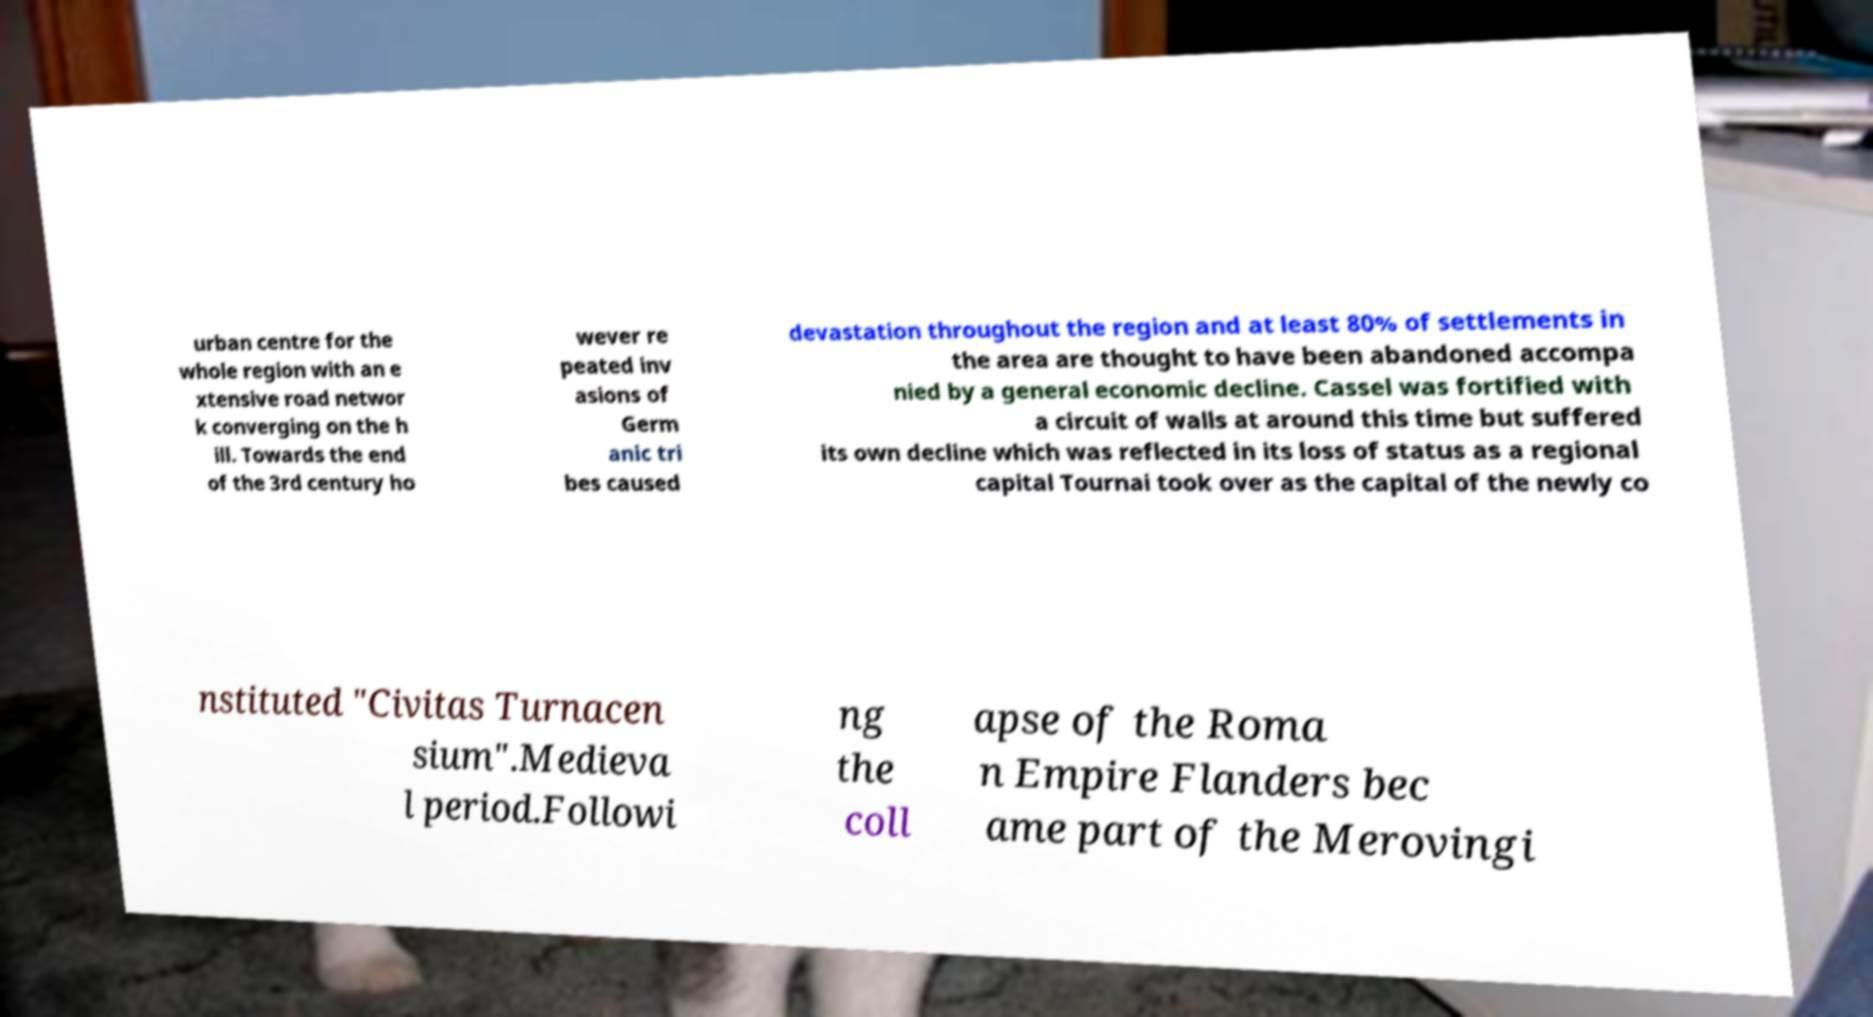There's text embedded in this image that I need extracted. Can you transcribe it verbatim? urban centre for the whole region with an e xtensive road networ k converging on the h ill. Towards the end of the 3rd century ho wever re peated inv asions of Germ anic tri bes caused devastation throughout the region and at least 80% of settlements in the area are thought to have been abandoned accompa nied by a general economic decline. Cassel was fortified with a circuit of walls at around this time but suffered its own decline which was reflected in its loss of status as a regional capital Tournai took over as the capital of the newly co nstituted "Civitas Turnacen sium".Medieva l period.Followi ng the coll apse of the Roma n Empire Flanders bec ame part of the Merovingi 